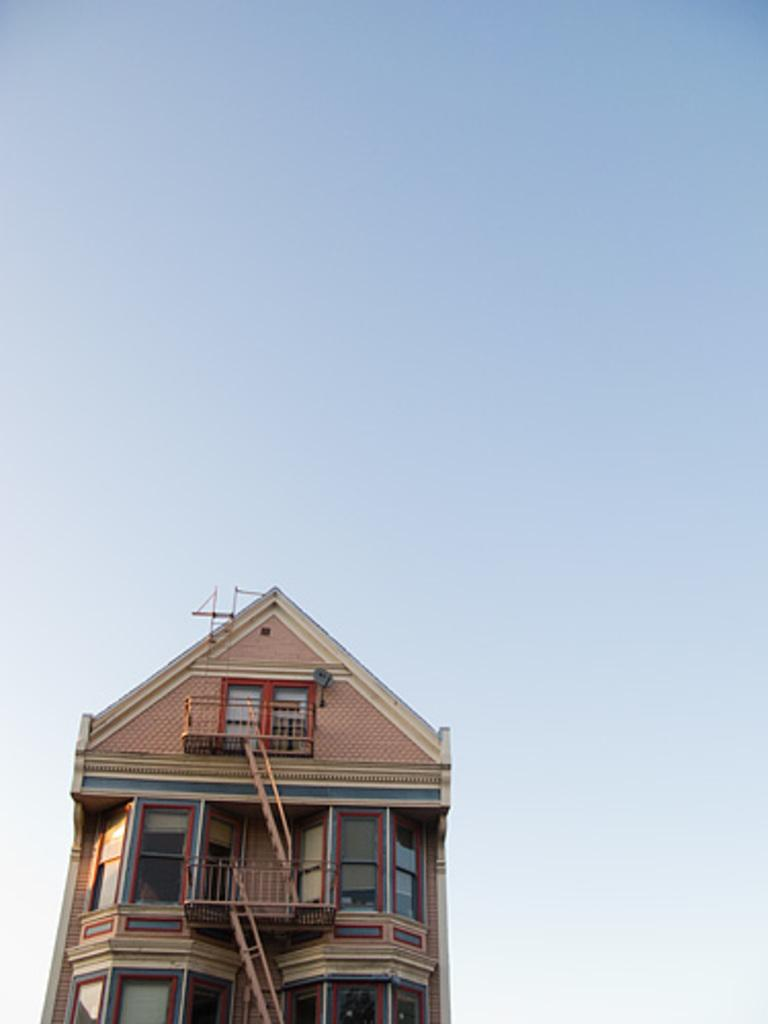What is the main subject of the picture? The main subject of the picture is a building. What specific features can be observed on the building? The building has windows. What can be seen in the background of the picture? The sky is visible in the background of the picture. Can you tell me how many impulses are guiding the sea in the image? There is no sea present in the image, and therefore no impulses guiding it. 